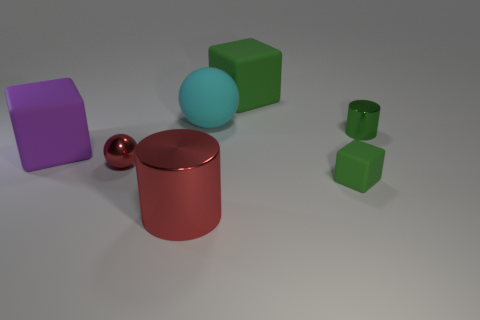The rubber object that is the same size as the metallic ball is what color?
Offer a terse response. Green. What number of matte objects are tiny objects or small gray things?
Your answer should be very brief. 1. How many things are both to the left of the tiny green metallic cylinder and in front of the large sphere?
Keep it short and to the point. 4. Is there anything else that is the same shape as the tiny green rubber object?
Your answer should be compact. Yes. What number of other objects are there of the same size as the green metal cylinder?
Give a very brief answer. 2. Do the red object that is behind the small green matte thing and the matte block that is in front of the purple thing have the same size?
Offer a very short reply. Yes. How many objects are large balls or metallic things that are to the left of the small rubber object?
Your response must be concise. 3. There is a green rubber cube behind the green metal cylinder; how big is it?
Your response must be concise. Large. Is the number of cyan objects that are in front of the tiny green cylinder less than the number of red metal objects behind the big red metallic cylinder?
Provide a short and direct response. Yes. The object that is both to the right of the large purple rubber block and left of the red metallic cylinder is made of what material?
Make the answer very short. Metal. 